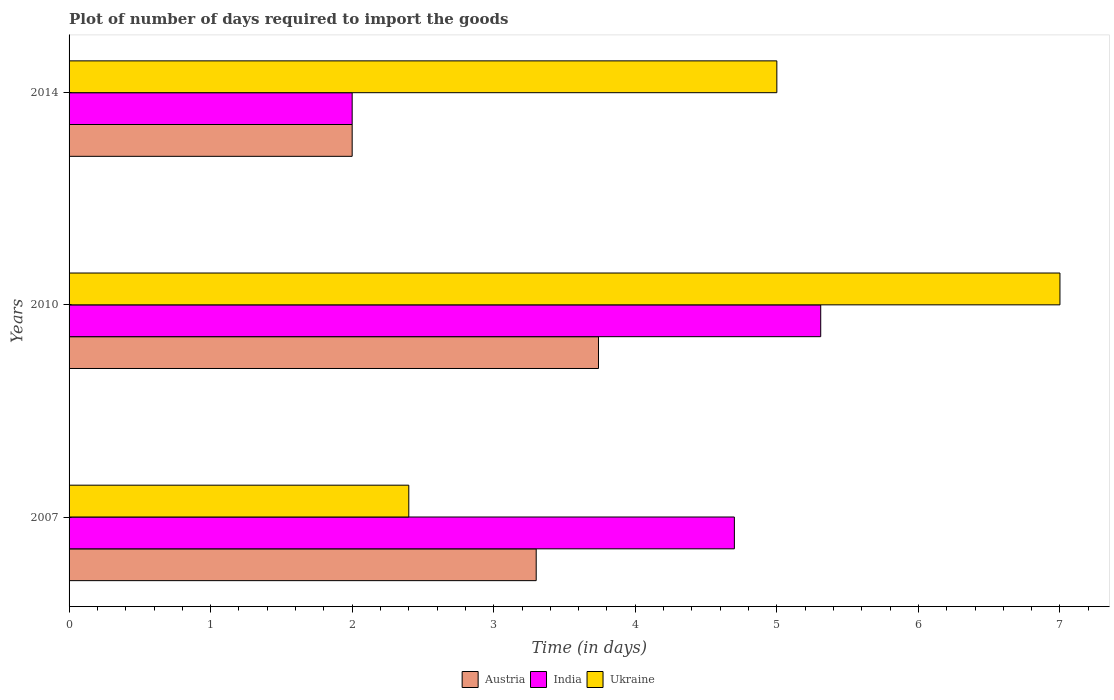How many groups of bars are there?
Make the answer very short. 3. What is the label of the 2nd group of bars from the top?
Keep it short and to the point. 2010. What is the time required to import goods in Austria in 2007?
Provide a short and direct response. 3.3. In which year was the time required to import goods in Austria maximum?
Give a very brief answer. 2010. What is the total time required to import goods in India in the graph?
Your response must be concise. 12.01. What is the difference between the time required to import goods in Ukraine in 2007 and that in 2010?
Make the answer very short. -4.6. What is the difference between the time required to import goods in Austria in 2014 and the time required to import goods in India in 2007?
Provide a succinct answer. -2.7. What is the average time required to import goods in India per year?
Keep it short and to the point. 4. In the year 2010, what is the difference between the time required to import goods in India and time required to import goods in Ukraine?
Provide a short and direct response. -1.69. What is the ratio of the time required to import goods in Austria in 2010 to that in 2014?
Your answer should be very brief. 1.87. Is the difference between the time required to import goods in India in 2010 and 2014 greater than the difference between the time required to import goods in Ukraine in 2010 and 2014?
Offer a very short reply. Yes. What is the difference between the highest and the second highest time required to import goods in India?
Your response must be concise. 0.61. What is the difference between the highest and the lowest time required to import goods in Ukraine?
Ensure brevity in your answer.  4.6. In how many years, is the time required to import goods in India greater than the average time required to import goods in India taken over all years?
Your answer should be compact. 2. Is the sum of the time required to import goods in Austria in 2007 and 2014 greater than the maximum time required to import goods in India across all years?
Give a very brief answer. No. What does the 3rd bar from the top in 2014 represents?
Give a very brief answer. Austria. What does the 3rd bar from the bottom in 2010 represents?
Your answer should be compact. Ukraine. Is it the case that in every year, the sum of the time required to import goods in Ukraine and time required to import goods in India is greater than the time required to import goods in Austria?
Your response must be concise. Yes. How many bars are there?
Your answer should be compact. 9. How many years are there in the graph?
Ensure brevity in your answer.  3. What is the difference between two consecutive major ticks on the X-axis?
Make the answer very short. 1. Where does the legend appear in the graph?
Ensure brevity in your answer.  Bottom center. How many legend labels are there?
Your answer should be compact. 3. What is the title of the graph?
Your answer should be compact. Plot of number of days required to import the goods. Does "Latin America(all income levels)" appear as one of the legend labels in the graph?
Offer a terse response. No. What is the label or title of the X-axis?
Keep it short and to the point. Time (in days). What is the Time (in days) in India in 2007?
Keep it short and to the point. 4.7. What is the Time (in days) in Ukraine in 2007?
Make the answer very short. 2.4. What is the Time (in days) of Austria in 2010?
Ensure brevity in your answer.  3.74. What is the Time (in days) in India in 2010?
Make the answer very short. 5.31. What is the Time (in days) in India in 2014?
Ensure brevity in your answer.  2. What is the Time (in days) in Ukraine in 2014?
Your answer should be very brief. 5. Across all years, what is the maximum Time (in days) of Austria?
Your answer should be compact. 3.74. Across all years, what is the maximum Time (in days) of India?
Offer a terse response. 5.31. What is the total Time (in days) in Austria in the graph?
Offer a very short reply. 9.04. What is the total Time (in days) in India in the graph?
Provide a short and direct response. 12.01. What is the total Time (in days) in Ukraine in the graph?
Keep it short and to the point. 14.4. What is the difference between the Time (in days) in Austria in 2007 and that in 2010?
Give a very brief answer. -0.44. What is the difference between the Time (in days) of India in 2007 and that in 2010?
Your response must be concise. -0.61. What is the difference between the Time (in days) of Ukraine in 2007 and that in 2010?
Your answer should be very brief. -4.6. What is the difference between the Time (in days) of Austria in 2007 and that in 2014?
Make the answer very short. 1.3. What is the difference between the Time (in days) in Austria in 2010 and that in 2014?
Your response must be concise. 1.74. What is the difference between the Time (in days) of India in 2010 and that in 2014?
Your response must be concise. 3.31. What is the difference between the Time (in days) in Austria in 2007 and the Time (in days) in India in 2010?
Your answer should be very brief. -2.01. What is the difference between the Time (in days) of India in 2007 and the Time (in days) of Ukraine in 2010?
Your answer should be compact. -2.3. What is the difference between the Time (in days) in Austria in 2007 and the Time (in days) in India in 2014?
Your answer should be compact. 1.3. What is the difference between the Time (in days) of India in 2007 and the Time (in days) of Ukraine in 2014?
Give a very brief answer. -0.3. What is the difference between the Time (in days) of Austria in 2010 and the Time (in days) of India in 2014?
Keep it short and to the point. 1.74. What is the difference between the Time (in days) in Austria in 2010 and the Time (in days) in Ukraine in 2014?
Ensure brevity in your answer.  -1.26. What is the difference between the Time (in days) in India in 2010 and the Time (in days) in Ukraine in 2014?
Ensure brevity in your answer.  0.31. What is the average Time (in days) of Austria per year?
Offer a terse response. 3.01. What is the average Time (in days) in India per year?
Offer a terse response. 4. What is the average Time (in days) of Ukraine per year?
Give a very brief answer. 4.8. In the year 2007, what is the difference between the Time (in days) of Austria and Time (in days) of Ukraine?
Make the answer very short. 0.9. In the year 2007, what is the difference between the Time (in days) of India and Time (in days) of Ukraine?
Offer a terse response. 2.3. In the year 2010, what is the difference between the Time (in days) of Austria and Time (in days) of India?
Offer a very short reply. -1.57. In the year 2010, what is the difference between the Time (in days) of Austria and Time (in days) of Ukraine?
Make the answer very short. -3.26. In the year 2010, what is the difference between the Time (in days) of India and Time (in days) of Ukraine?
Make the answer very short. -1.69. In the year 2014, what is the difference between the Time (in days) of Austria and Time (in days) of India?
Provide a succinct answer. 0. In the year 2014, what is the difference between the Time (in days) in India and Time (in days) in Ukraine?
Offer a very short reply. -3. What is the ratio of the Time (in days) in Austria in 2007 to that in 2010?
Your answer should be very brief. 0.88. What is the ratio of the Time (in days) of India in 2007 to that in 2010?
Offer a terse response. 0.89. What is the ratio of the Time (in days) in Ukraine in 2007 to that in 2010?
Your response must be concise. 0.34. What is the ratio of the Time (in days) in Austria in 2007 to that in 2014?
Your answer should be very brief. 1.65. What is the ratio of the Time (in days) of India in 2007 to that in 2014?
Offer a terse response. 2.35. What is the ratio of the Time (in days) in Ukraine in 2007 to that in 2014?
Give a very brief answer. 0.48. What is the ratio of the Time (in days) of Austria in 2010 to that in 2014?
Keep it short and to the point. 1.87. What is the ratio of the Time (in days) of India in 2010 to that in 2014?
Offer a terse response. 2.65. What is the difference between the highest and the second highest Time (in days) in Austria?
Your answer should be very brief. 0.44. What is the difference between the highest and the second highest Time (in days) of India?
Ensure brevity in your answer.  0.61. What is the difference between the highest and the lowest Time (in days) of Austria?
Ensure brevity in your answer.  1.74. What is the difference between the highest and the lowest Time (in days) of India?
Your answer should be very brief. 3.31. What is the difference between the highest and the lowest Time (in days) in Ukraine?
Make the answer very short. 4.6. 